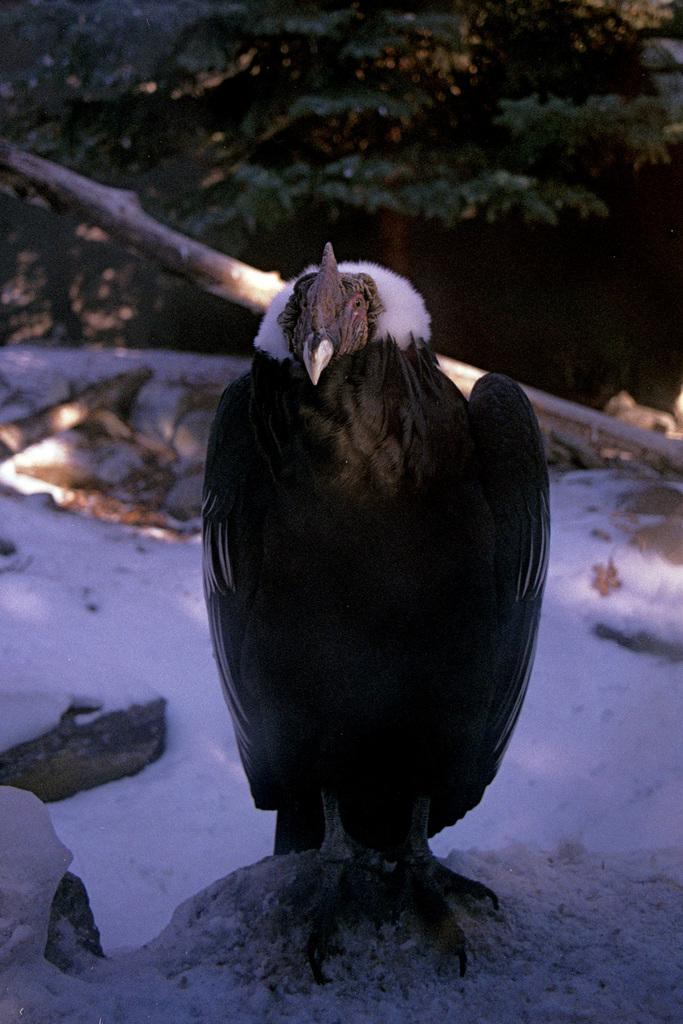What type of animal can be seen in the image? There is a bird in the image. What is the bird standing on? The bird is standing on the snow. What can be seen in the background of the image? There are trees in the background of the image. What activity is the bird's father participating in the image? There is no father or activity involving the bird in the image. The bird is simply standing on the snow with trees in the background. 